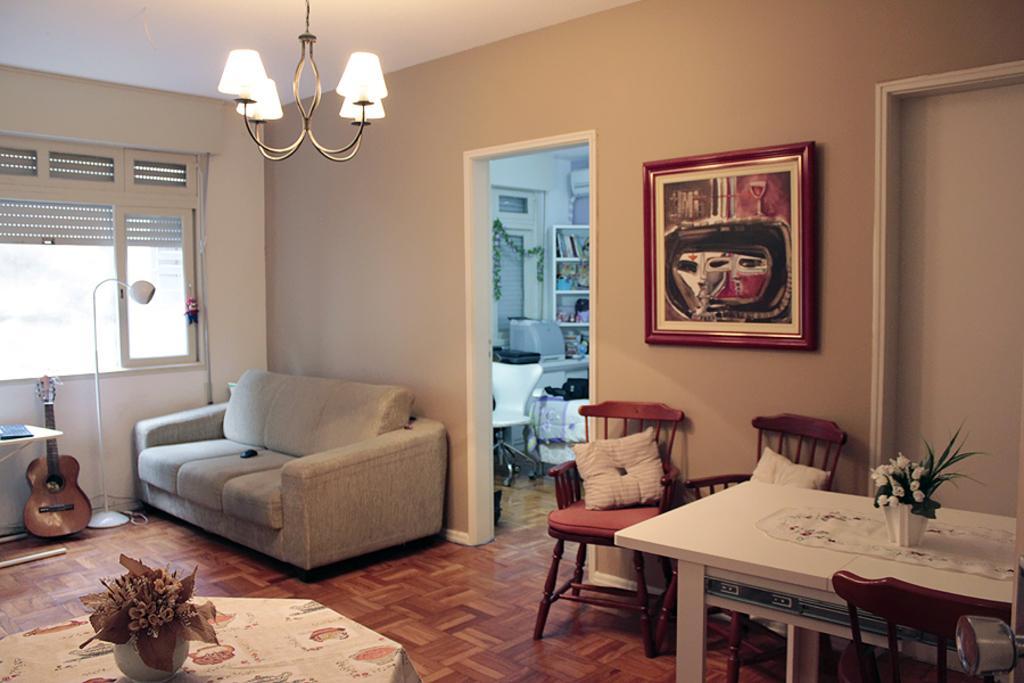Could you give a brief overview of what you see in this image? In this picture we can see a room with sofa at one end stand and lamp guitar, chair, table and on chair there are pillows and here it is a wall and frame inside the other room there are racks full of door and here is a table we can see flower vase. 